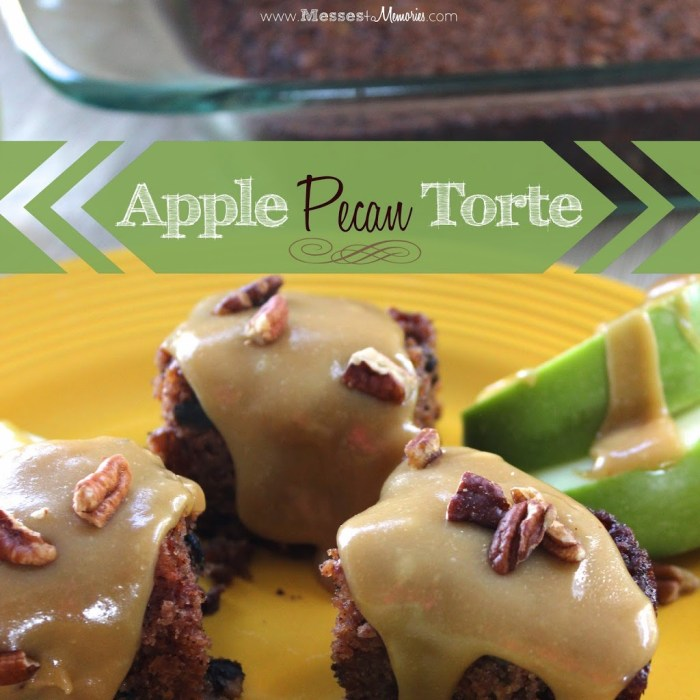How might serving this dessert with a particular beverage accentuate its flavors? Serving this apple pecan torte with a cup of hot cinnamon tea or a freshly brewed coffee could beautifully accentuate its flavors. The warm spices in the cinnamon tea would echo the dessert's spice undertones, while the bitterness of coffee provides a delightful contrast to its sweet and rich caramel and fruit components. Alternatively, a glass of apple cider could enhance the apple profiles, making for a harmonious and thematic pairing. 